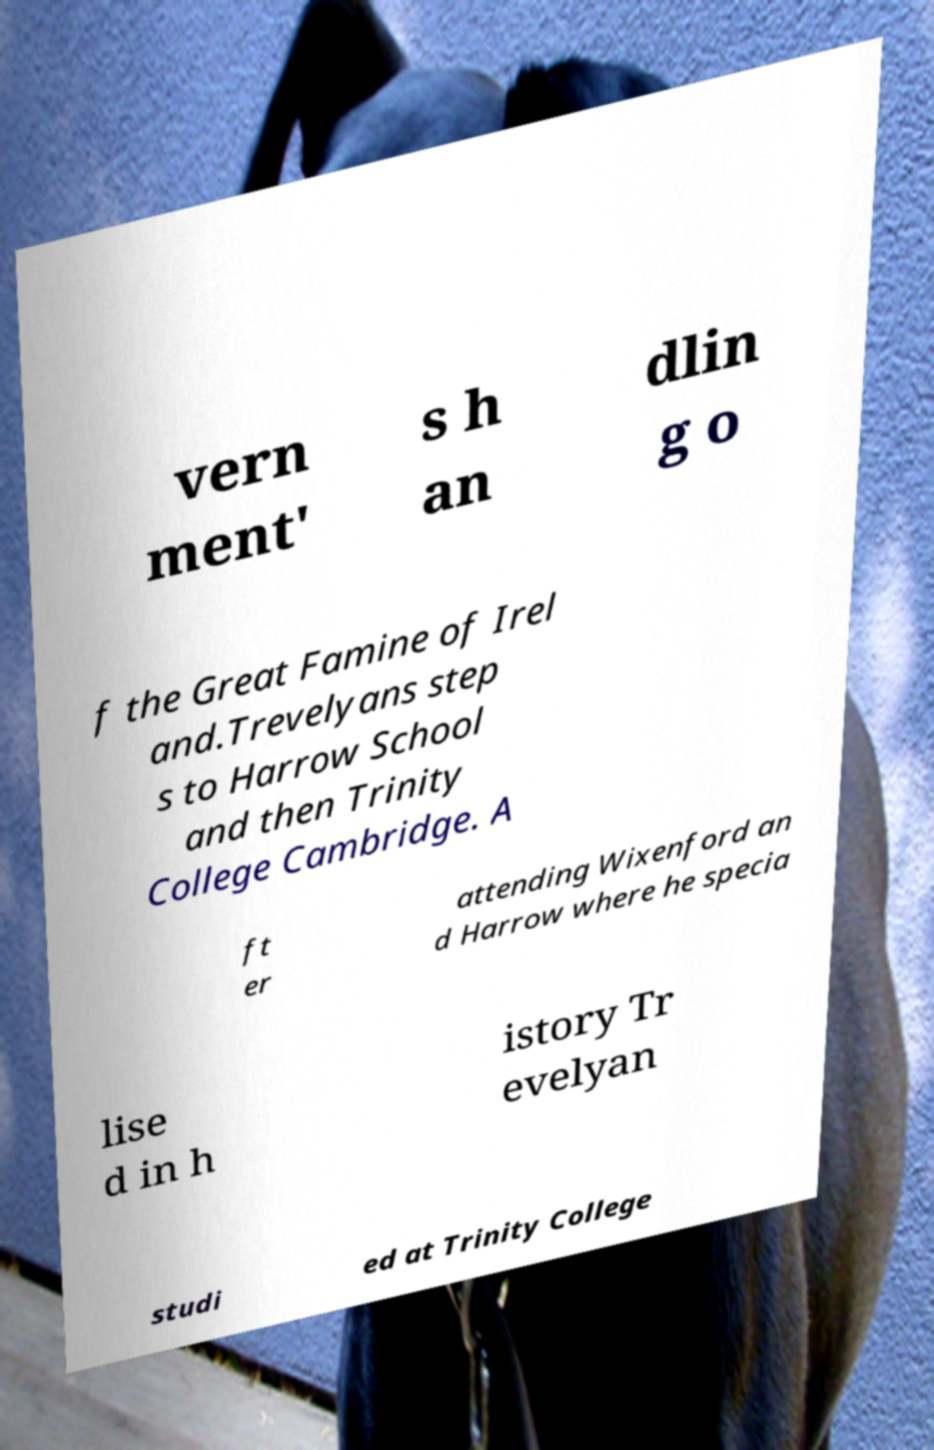Can you accurately transcribe the text from the provided image for me? vern ment' s h an dlin g o f the Great Famine of Irel and.Trevelyans step s to Harrow School and then Trinity College Cambridge. A ft er attending Wixenford an d Harrow where he specia lise d in h istory Tr evelyan studi ed at Trinity College 